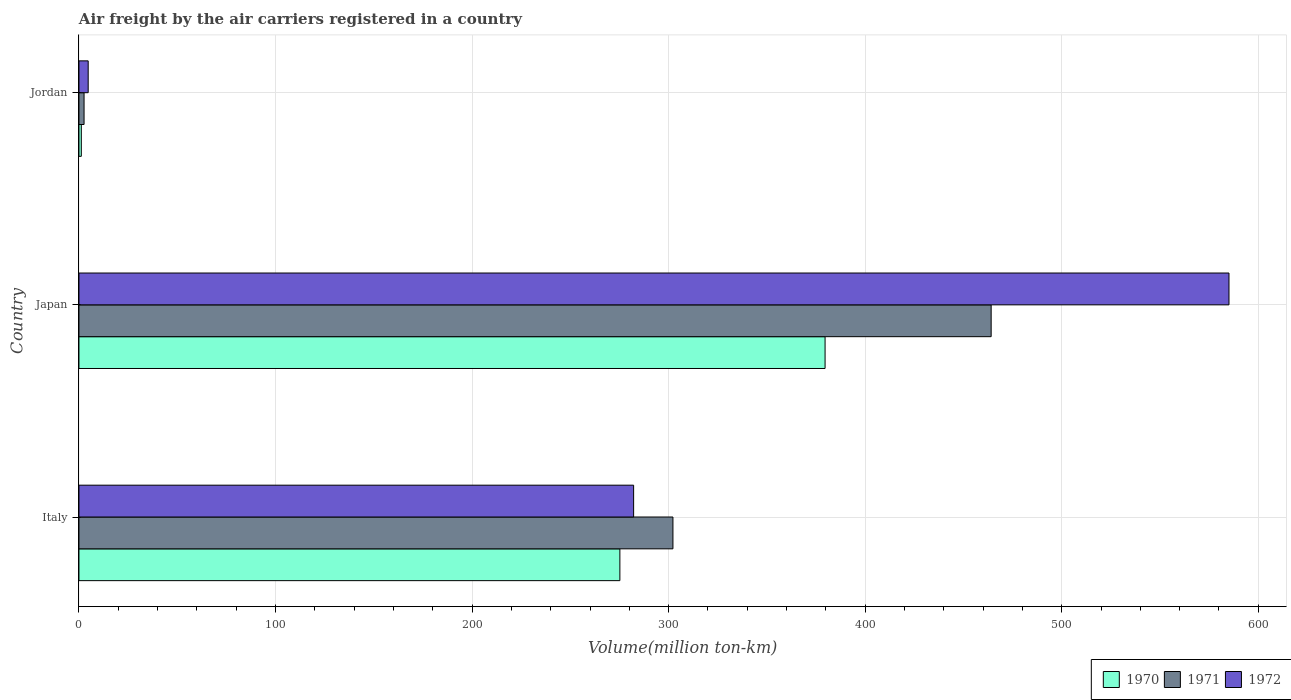Are the number of bars per tick equal to the number of legend labels?
Give a very brief answer. Yes. Are the number of bars on each tick of the Y-axis equal?
Make the answer very short. Yes. How many bars are there on the 1st tick from the top?
Your answer should be compact. 3. What is the volume of the air carriers in 1972 in Jordan?
Offer a very short reply. 4.7. Across all countries, what is the maximum volume of the air carriers in 1971?
Make the answer very short. 464.1. Across all countries, what is the minimum volume of the air carriers in 1972?
Ensure brevity in your answer.  4.7. In which country was the volume of the air carriers in 1970 minimum?
Provide a short and direct response. Jordan. What is the total volume of the air carriers in 1971 in the graph?
Provide a succinct answer. 768.9. What is the difference between the volume of the air carriers in 1971 in Japan and that in Jordan?
Offer a terse response. 461.5. What is the difference between the volume of the air carriers in 1971 in Italy and the volume of the air carriers in 1972 in Japan?
Provide a succinct answer. -282.9. What is the average volume of the air carriers in 1972 per country?
Provide a succinct answer. 290.67. In how many countries, is the volume of the air carriers in 1972 greater than 520 million ton-km?
Ensure brevity in your answer.  1. What is the ratio of the volume of the air carriers in 1970 in Italy to that in Jordan?
Your response must be concise. 229.33. What is the difference between the highest and the second highest volume of the air carriers in 1972?
Make the answer very short. 302.9. What is the difference between the highest and the lowest volume of the air carriers in 1971?
Your response must be concise. 461.5. Is the sum of the volume of the air carriers in 1970 in Italy and Japan greater than the maximum volume of the air carriers in 1972 across all countries?
Your answer should be very brief. Yes. How many bars are there?
Offer a very short reply. 9. How many countries are there in the graph?
Keep it short and to the point. 3. Are the values on the major ticks of X-axis written in scientific E-notation?
Offer a terse response. No. Does the graph contain any zero values?
Offer a terse response. No. Does the graph contain grids?
Your answer should be very brief. Yes. Where does the legend appear in the graph?
Make the answer very short. Bottom right. What is the title of the graph?
Keep it short and to the point. Air freight by the air carriers registered in a country. Does "1965" appear as one of the legend labels in the graph?
Ensure brevity in your answer.  No. What is the label or title of the X-axis?
Offer a terse response. Volume(million ton-km). What is the label or title of the Y-axis?
Provide a succinct answer. Country. What is the Volume(million ton-km) of 1970 in Italy?
Give a very brief answer. 275.2. What is the Volume(million ton-km) of 1971 in Italy?
Offer a very short reply. 302.2. What is the Volume(million ton-km) in 1972 in Italy?
Your response must be concise. 282.2. What is the Volume(million ton-km) in 1970 in Japan?
Your response must be concise. 379.6. What is the Volume(million ton-km) of 1971 in Japan?
Your answer should be very brief. 464.1. What is the Volume(million ton-km) of 1972 in Japan?
Provide a succinct answer. 585.1. What is the Volume(million ton-km) of 1970 in Jordan?
Offer a terse response. 1.2. What is the Volume(million ton-km) of 1971 in Jordan?
Your answer should be compact. 2.6. What is the Volume(million ton-km) in 1972 in Jordan?
Offer a very short reply. 4.7. Across all countries, what is the maximum Volume(million ton-km) in 1970?
Offer a very short reply. 379.6. Across all countries, what is the maximum Volume(million ton-km) of 1971?
Provide a succinct answer. 464.1. Across all countries, what is the maximum Volume(million ton-km) of 1972?
Provide a short and direct response. 585.1. Across all countries, what is the minimum Volume(million ton-km) of 1970?
Provide a short and direct response. 1.2. Across all countries, what is the minimum Volume(million ton-km) of 1971?
Give a very brief answer. 2.6. Across all countries, what is the minimum Volume(million ton-km) in 1972?
Provide a short and direct response. 4.7. What is the total Volume(million ton-km) of 1970 in the graph?
Make the answer very short. 656. What is the total Volume(million ton-km) of 1971 in the graph?
Give a very brief answer. 768.9. What is the total Volume(million ton-km) in 1972 in the graph?
Your response must be concise. 872. What is the difference between the Volume(million ton-km) of 1970 in Italy and that in Japan?
Offer a terse response. -104.4. What is the difference between the Volume(million ton-km) of 1971 in Italy and that in Japan?
Make the answer very short. -161.9. What is the difference between the Volume(million ton-km) in 1972 in Italy and that in Japan?
Provide a succinct answer. -302.9. What is the difference between the Volume(million ton-km) in 1970 in Italy and that in Jordan?
Offer a terse response. 274. What is the difference between the Volume(million ton-km) of 1971 in Italy and that in Jordan?
Your answer should be very brief. 299.6. What is the difference between the Volume(million ton-km) in 1972 in Italy and that in Jordan?
Your answer should be compact. 277.5. What is the difference between the Volume(million ton-km) of 1970 in Japan and that in Jordan?
Provide a short and direct response. 378.4. What is the difference between the Volume(million ton-km) in 1971 in Japan and that in Jordan?
Your response must be concise. 461.5. What is the difference between the Volume(million ton-km) of 1972 in Japan and that in Jordan?
Your answer should be very brief. 580.4. What is the difference between the Volume(million ton-km) of 1970 in Italy and the Volume(million ton-km) of 1971 in Japan?
Provide a succinct answer. -188.9. What is the difference between the Volume(million ton-km) of 1970 in Italy and the Volume(million ton-km) of 1972 in Japan?
Offer a very short reply. -309.9. What is the difference between the Volume(million ton-km) of 1971 in Italy and the Volume(million ton-km) of 1972 in Japan?
Offer a very short reply. -282.9. What is the difference between the Volume(million ton-km) of 1970 in Italy and the Volume(million ton-km) of 1971 in Jordan?
Give a very brief answer. 272.6. What is the difference between the Volume(million ton-km) of 1970 in Italy and the Volume(million ton-km) of 1972 in Jordan?
Offer a very short reply. 270.5. What is the difference between the Volume(million ton-km) of 1971 in Italy and the Volume(million ton-km) of 1972 in Jordan?
Your response must be concise. 297.5. What is the difference between the Volume(million ton-km) in 1970 in Japan and the Volume(million ton-km) in 1971 in Jordan?
Ensure brevity in your answer.  377. What is the difference between the Volume(million ton-km) of 1970 in Japan and the Volume(million ton-km) of 1972 in Jordan?
Your answer should be compact. 374.9. What is the difference between the Volume(million ton-km) of 1971 in Japan and the Volume(million ton-km) of 1972 in Jordan?
Your response must be concise. 459.4. What is the average Volume(million ton-km) of 1970 per country?
Offer a very short reply. 218.67. What is the average Volume(million ton-km) in 1971 per country?
Provide a short and direct response. 256.3. What is the average Volume(million ton-km) of 1972 per country?
Offer a very short reply. 290.67. What is the difference between the Volume(million ton-km) of 1970 and Volume(million ton-km) of 1971 in Italy?
Your answer should be very brief. -27. What is the difference between the Volume(million ton-km) in 1971 and Volume(million ton-km) in 1972 in Italy?
Offer a terse response. 20. What is the difference between the Volume(million ton-km) of 1970 and Volume(million ton-km) of 1971 in Japan?
Offer a terse response. -84.5. What is the difference between the Volume(million ton-km) of 1970 and Volume(million ton-km) of 1972 in Japan?
Provide a short and direct response. -205.5. What is the difference between the Volume(million ton-km) in 1971 and Volume(million ton-km) in 1972 in Japan?
Your answer should be compact. -121. What is the difference between the Volume(million ton-km) in 1970 and Volume(million ton-km) in 1971 in Jordan?
Give a very brief answer. -1.4. What is the ratio of the Volume(million ton-km) of 1970 in Italy to that in Japan?
Give a very brief answer. 0.72. What is the ratio of the Volume(million ton-km) of 1971 in Italy to that in Japan?
Give a very brief answer. 0.65. What is the ratio of the Volume(million ton-km) of 1972 in Italy to that in Japan?
Give a very brief answer. 0.48. What is the ratio of the Volume(million ton-km) in 1970 in Italy to that in Jordan?
Your answer should be compact. 229.33. What is the ratio of the Volume(million ton-km) of 1971 in Italy to that in Jordan?
Offer a terse response. 116.23. What is the ratio of the Volume(million ton-km) in 1972 in Italy to that in Jordan?
Your answer should be compact. 60.04. What is the ratio of the Volume(million ton-km) of 1970 in Japan to that in Jordan?
Your response must be concise. 316.33. What is the ratio of the Volume(million ton-km) in 1971 in Japan to that in Jordan?
Make the answer very short. 178.5. What is the ratio of the Volume(million ton-km) of 1972 in Japan to that in Jordan?
Your answer should be very brief. 124.49. What is the difference between the highest and the second highest Volume(million ton-km) in 1970?
Keep it short and to the point. 104.4. What is the difference between the highest and the second highest Volume(million ton-km) in 1971?
Give a very brief answer. 161.9. What is the difference between the highest and the second highest Volume(million ton-km) of 1972?
Make the answer very short. 302.9. What is the difference between the highest and the lowest Volume(million ton-km) of 1970?
Your response must be concise. 378.4. What is the difference between the highest and the lowest Volume(million ton-km) of 1971?
Keep it short and to the point. 461.5. What is the difference between the highest and the lowest Volume(million ton-km) in 1972?
Your response must be concise. 580.4. 